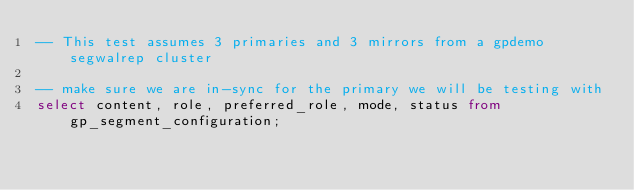<code> <loc_0><loc_0><loc_500><loc_500><_SQL_>-- This test assumes 3 primaries and 3 mirrors from a gpdemo segwalrep cluster

-- make sure we are in-sync for the primary we will be testing with
select content, role, preferred_role, mode, status from gp_segment_configuration;
</code> 